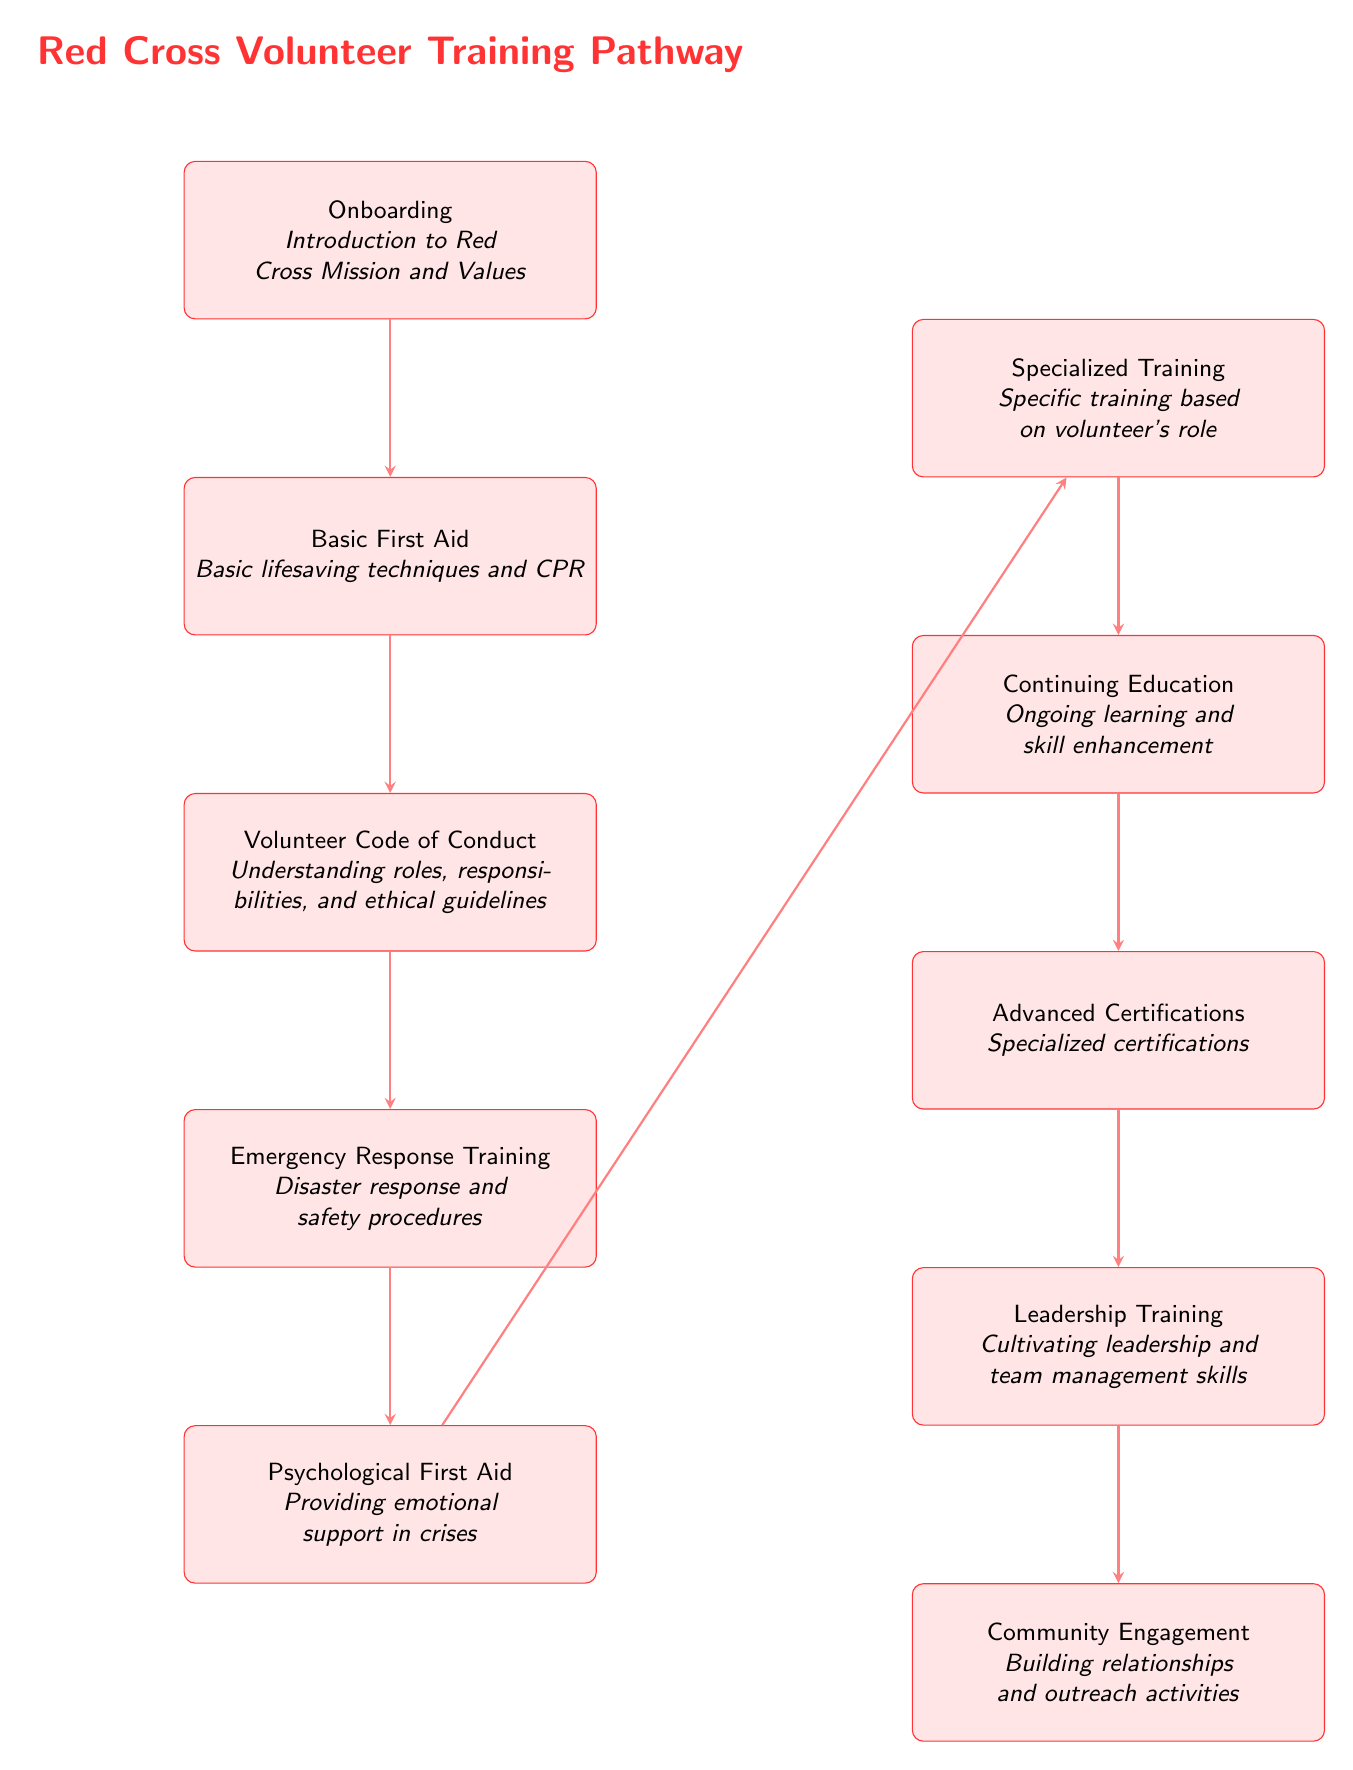What is the first step in the training pathway? The first step is labeled as "Onboarding," which introduces volunteers to the Red Cross Mission and Values.
Answer: Onboarding How many training stages are shown in the diagram? The diagram consists of a total of nine training stages, ranging from Onboarding to Community Engagement.
Answer: Nine What training follows Basic First Aid? The training stage that follows Basic First Aid is called "Volunteer Code of Conduct," focusing on understanding roles, responsibilities, and ethical guidelines.
Answer: Volunteer Code of Conduct What is the last training stage in the pathway? The last training stage is labeled as "Community Engagement," which emphasizes building relationships and outreach activities.
Answer: Community Engagement Which stage emphasizes emotional support in crises? The stage that emphasizes providing emotional support in crises is called "Psychological First Aid."
Answer: Psychological First Aid What training comes after Specialized Training? After Specialized Training, the next stage is "Continuing Education," which focuses on ongoing learning and skill enhancement.
Answer: Continuing Education What are the last two stages of the training pathway? The last two stages are "Advanced Certifications," which offer specialized certifications, followed by "Leadership Training," which cultivates leadership and team management skills.
Answer: Advanced Certifications and Leadership Training How do volunteers progress from Emergency Response Training? Volunteers progress from "Emergency Response Training" to "Psychological First Aid" as they continue their training pathway.
Answer: Psychological First Aid What type of training follows the initial onboarding? After the initial onboarding, the next type of training is "Basic First Aid," which covers basic lifesaving techniques and CPR.
Answer: Basic First Aid 